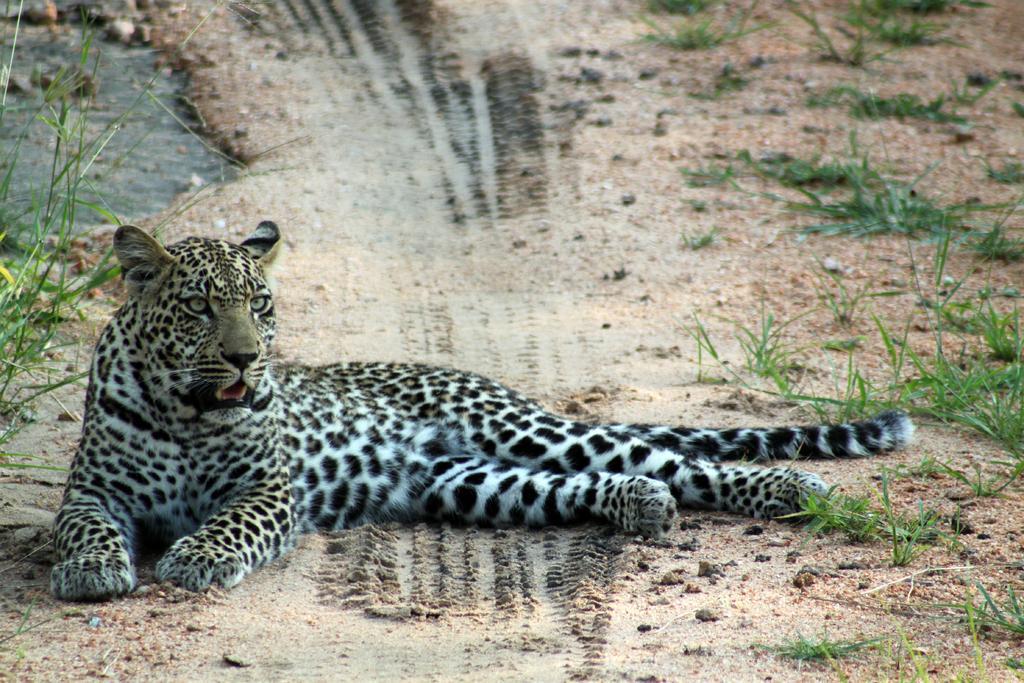Describe this image in one or two sentences. In this image, we can see leopard is laying on the ground. In this image, we can see grass and plants. 